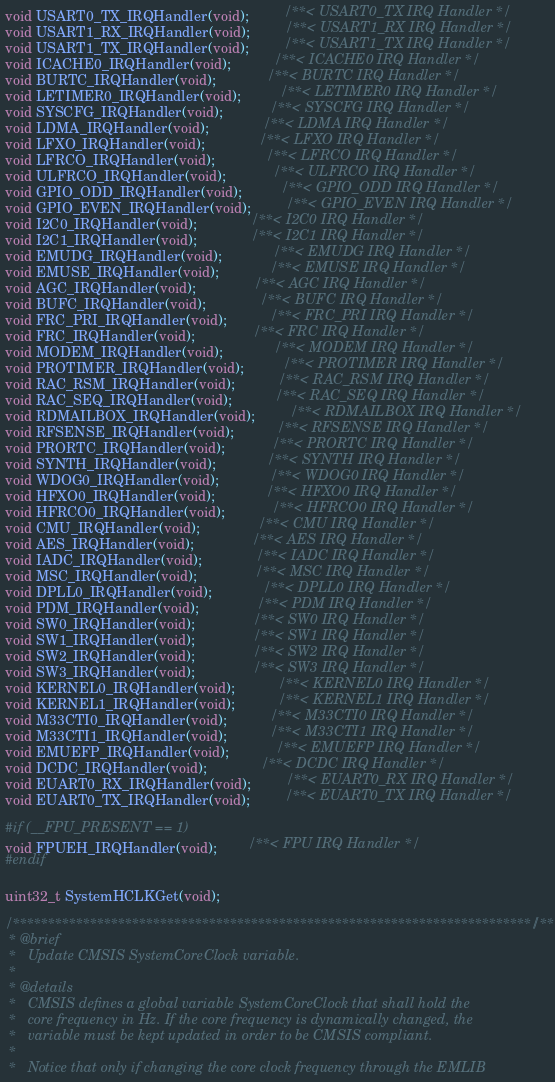Convert code to text. <code><loc_0><loc_0><loc_500><loc_500><_C_>void USART0_TX_IRQHandler(void);         /**< USART0_TX IRQ Handler */
void USART1_RX_IRQHandler(void);         /**< USART1_RX IRQ Handler */
void USART1_TX_IRQHandler(void);         /**< USART1_TX IRQ Handler */
void ICACHE0_IRQHandler(void);           /**< ICACHE0 IRQ Handler */
void BURTC_IRQHandler(void);             /**< BURTC IRQ Handler */
void LETIMER0_IRQHandler(void);          /**< LETIMER0 IRQ Handler */
void SYSCFG_IRQHandler(void);            /**< SYSCFG IRQ Handler */
void LDMA_IRQHandler(void);              /**< LDMA IRQ Handler */
void LFXO_IRQHandler(void);              /**< LFXO IRQ Handler */
void LFRCO_IRQHandler(void);             /**< LFRCO IRQ Handler */
void ULFRCO_IRQHandler(void);            /**< ULFRCO IRQ Handler */
void GPIO_ODD_IRQHandler(void);          /**< GPIO_ODD IRQ Handler */
void GPIO_EVEN_IRQHandler(void);         /**< GPIO_EVEN IRQ Handler */
void I2C0_IRQHandler(void);              /**< I2C0 IRQ Handler */
void I2C1_IRQHandler(void);              /**< I2C1 IRQ Handler */
void EMUDG_IRQHandler(void);             /**< EMUDG IRQ Handler */
void EMUSE_IRQHandler(void);             /**< EMUSE IRQ Handler */
void AGC_IRQHandler(void);               /**< AGC IRQ Handler */
void BUFC_IRQHandler(void);              /**< BUFC IRQ Handler */
void FRC_PRI_IRQHandler(void);           /**< FRC_PRI IRQ Handler */
void FRC_IRQHandler(void);               /**< FRC IRQ Handler */
void MODEM_IRQHandler(void);             /**< MODEM IRQ Handler */
void PROTIMER_IRQHandler(void);          /**< PROTIMER IRQ Handler */
void RAC_RSM_IRQHandler(void);           /**< RAC_RSM IRQ Handler */
void RAC_SEQ_IRQHandler(void);           /**< RAC_SEQ IRQ Handler */
void RDMAILBOX_IRQHandler(void);         /**< RDMAILBOX IRQ Handler */
void RFSENSE_IRQHandler(void);           /**< RFSENSE IRQ Handler */
void PRORTC_IRQHandler(void);            /**< PRORTC IRQ Handler */
void SYNTH_IRQHandler(void);             /**< SYNTH IRQ Handler */
void WDOG0_IRQHandler(void);             /**< WDOG0 IRQ Handler */
void HFXO0_IRQHandler(void);             /**< HFXO0 IRQ Handler */
void HFRCO0_IRQHandler(void);            /**< HFRCO0 IRQ Handler */
void CMU_IRQHandler(void);               /**< CMU IRQ Handler */
void AES_IRQHandler(void);               /**< AES IRQ Handler */
void IADC_IRQHandler(void);              /**< IADC IRQ Handler */
void MSC_IRQHandler(void);               /**< MSC IRQ Handler */
void DPLL0_IRQHandler(void);             /**< DPLL0 IRQ Handler */
void PDM_IRQHandler(void);               /**< PDM IRQ Handler */
void SW0_IRQHandler(void);               /**< SW0 IRQ Handler */
void SW1_IRQHandler(void);               /**< SW1 IRQ Handler */
void SW2_IRQHandler(void);               /**< SW2 IRQ Handler */
void SW3_IRQHandler(void);               /**< SW3 IRQ Handler */
void KERNEL0_IRQHandler(void);           /**< KERNEL0 IRQ Handler */
void KERNEL1_IRQHandler(void);           /**< KERNEL1 IRQ Handler */
void M33CTI0_IRQHandler(void);           /**< M33CTI0 IRQ Handler */
void M33CTI1_IRQHandler(void);           /**< M33CTI1 IRQ Handler */
void EMUEFP_IRQHandler(void);            /**< EMUEFP IRQ Handler */
void DCDC_IRQHandler(void);              /**< DCDC IRQ Handler */
void EUART0_RX_IRQHandler(void);         /**< EUART0_RX IRQ Handler */
void EUART0_TX_IRQHandler(void);         /**< EUART0_TX IRQ Handler */

#if (__FPU_PRESENT == 1)
void FPUEH_IRQHandler(void);        /**< FPU IRQ Handler */
#endif

uint32_t SystemHCLKGet(void);

/**************************************************************************//**
 * @brief
 *   Update CMSIS SystemCoreClock variable.
 *
 * @details
 *   CMSIS defines a global variable SystemCoreClock that shall hold the
 *   core frequency in Hz. If the core frequency is dynamically changed, the
 *   variable must be kept updated in order to be CMSIS compliant.
 *
 *   Notice that only if changing the core clock frequency through the EMLIB</code> 